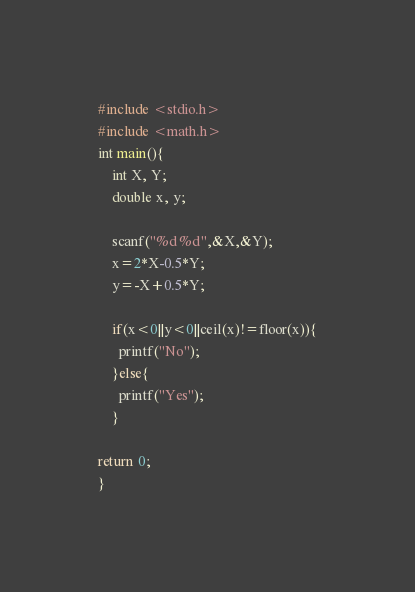Convert code to text. <code><loc_0><loc_0><loc_500><loc_500><_C_>#include <stdio.h>
#include <math.h>
int main(){
    int X, Y;
    double x, y;

    scanf("%d %d",&X,&Y);
    x=2*X-0.5*Y;
    y=-X+0.5*Y;

    if(x<0||y<0||ceil(x)!=floor(x)){
      printf("No");
    }else{
      printf("Yes");
    }

return 0;
}</code> 